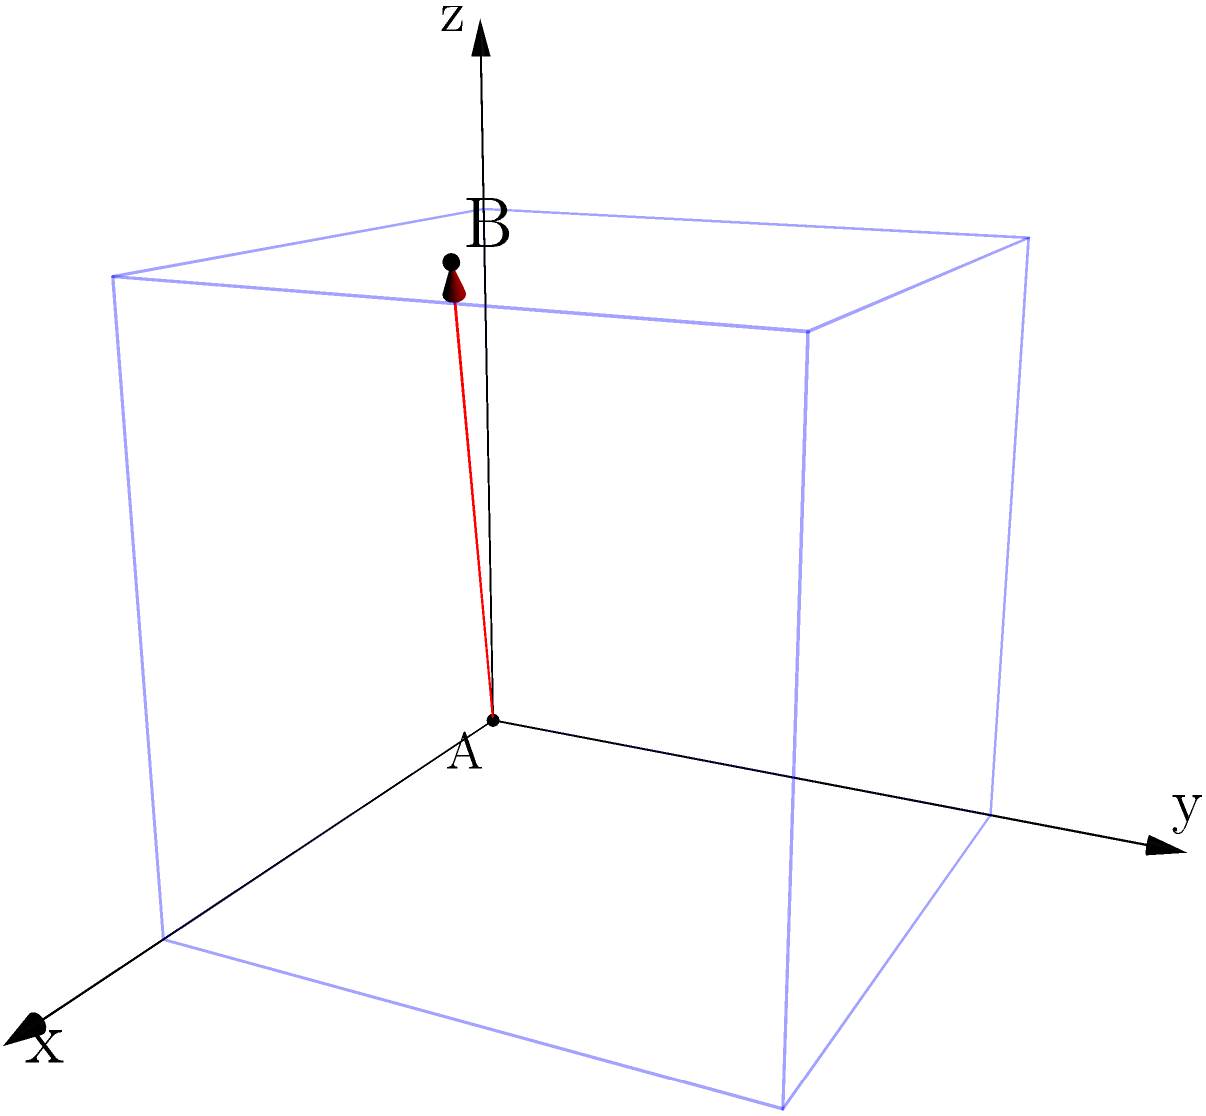A waste item enters your segregation device at point A (0, 0, 0) and needs to reach point B (2, 1, 3) for proper sorting. Calculate the magnitude of the displacement vector $\vec{AB}$ representing the optimal path for the waste item through the device. To solve this problem, we need to follow these steps:

1) First, we identify the displacement vector $\vec{AB}$. This vector represents the difference between the final position (point B) and the initial position (point A).

   $\vec{AB} = B - A = (2-0, 1-0, 3-0) = (2, 1, 3)$

2) Now that we have the components of the displacement vector, we can calculate its magnitude using the three-dimensional version of the Pythagorean theorem:

   $|\vec{AB}| = \sqrt{(x_2-x_1)^2 + (y_2-y_1)^2 + (z_2-z_1)^2}$

3) Substituting our values:

   $|\vec{AB}| = \sqrt{2^2 + 1^2 + 3^2}$

4) Simplify:

   $|\vec{AB}| = \sqrt{4 + 1 + 9} = \sqrt{14}$

5) The square root of 14 cannot be simplified further, so this is our final answer.

Therefore, the magnitude of the displacement vector $\vec{AB}$, representing the optimal path for the waste item through the device, is $\sqrt{14}$ units.
Answer: $\sqrt{14}$ units 